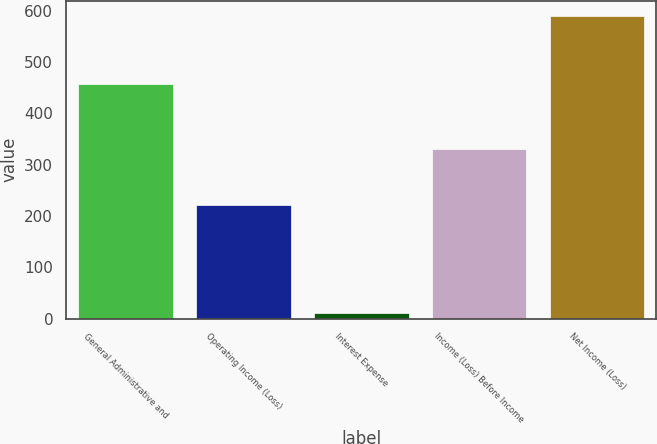<chart> <loc_0><loc_0><loc_500><loc_500><bar_chart><fcel>General Administrative and<fcel>Operating Income (Loss)<fcel>Interest Expense<fcel>Income (Loss) Before Income<fcel>Net Income (Loss)<nl><fcel>457<fcel>222<fcel>11<fcel>330<fcel>590<nl></chart> 